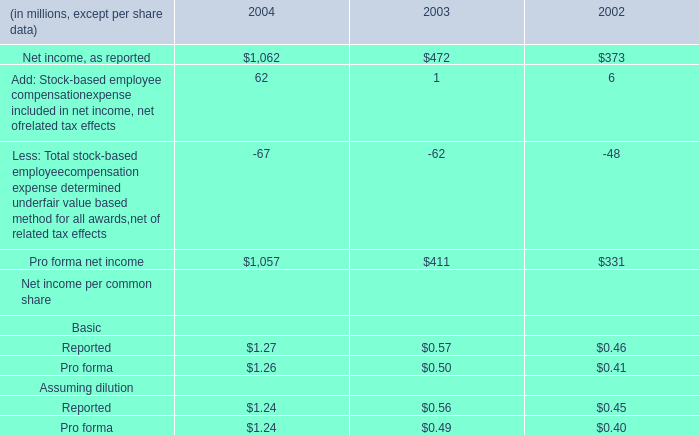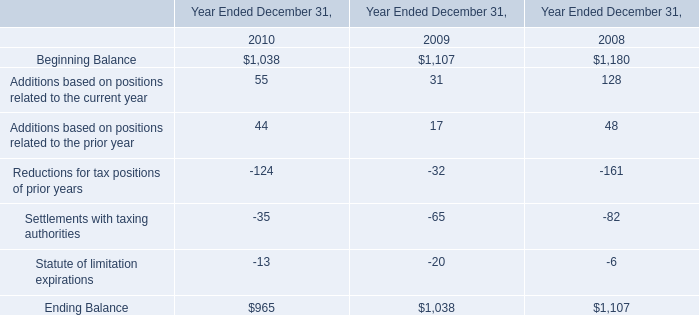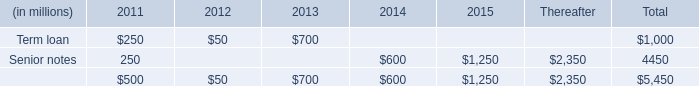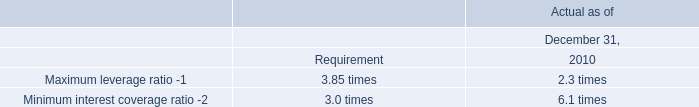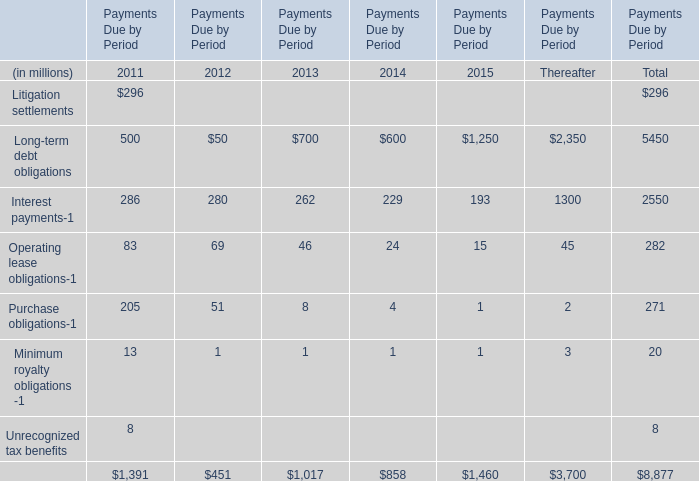What's the average of Senior notes of 2015, and Beginning Balance of Year Ended December 31, 2010 ? 
Computations: ((1250.0 + 1038.0) / 2)
Answer: 1144.0. 